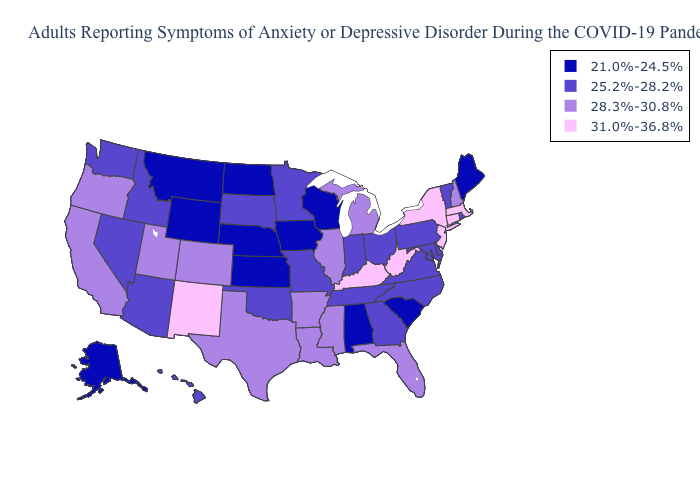What is the value of Louisiana?
Write a very short answer. 28.3%-30.8%. Does the first symbol in the legend represent the smallest category?
Be succinct. Yes. What is the value of Washington?
Quick response, please. 25.2%-28.2%. Name the states that have a value in the range 25.2%-28.2%?
Short answer required. Arizona, Delaware, Georgia, Hawaii, Idaho, Indiana, Maryland, Minnesota, Missouri, Nevada, North Carolina, Ohio, Oklahoma, Pennsylvania, Rhode Island, South Dakota, Tennessee, Vermont, Virginia, Washington. What is the highest value in states that border Idaho?
Quick response, please. 28.3%-30.8%. What is the value of Michigan?
Keep it brief. 28.3%-30.8%. What is the value of Arizona?
Quick response, please. 25.2%-28.2%. What is the value of California?
Write a very short answer. 28.3%-30.8%. Does Connecticut have the same value as Colorado?
Give a very brief answer. No. Among the states that border West Virginia , which have the lowest value?
Answer briefly. Maryland, Ohio, Pennsylvania, Virginia. What is the lowest value in states that border Kentucky?
Be succinct. 25.2%-28.2%. How many symbols are there in the legend?
Keep it brief. 4. Which states have the lowest value in the MidWest?
Concise answer only. Iowa, Kansas, Nebraska, North Dakota, Wisconsin. What is the highest value in the Northeast ?
Be succinct. 31.0%-36.8%. What is the value of New York?
Keep it brief. 31.0%-36.8%. 